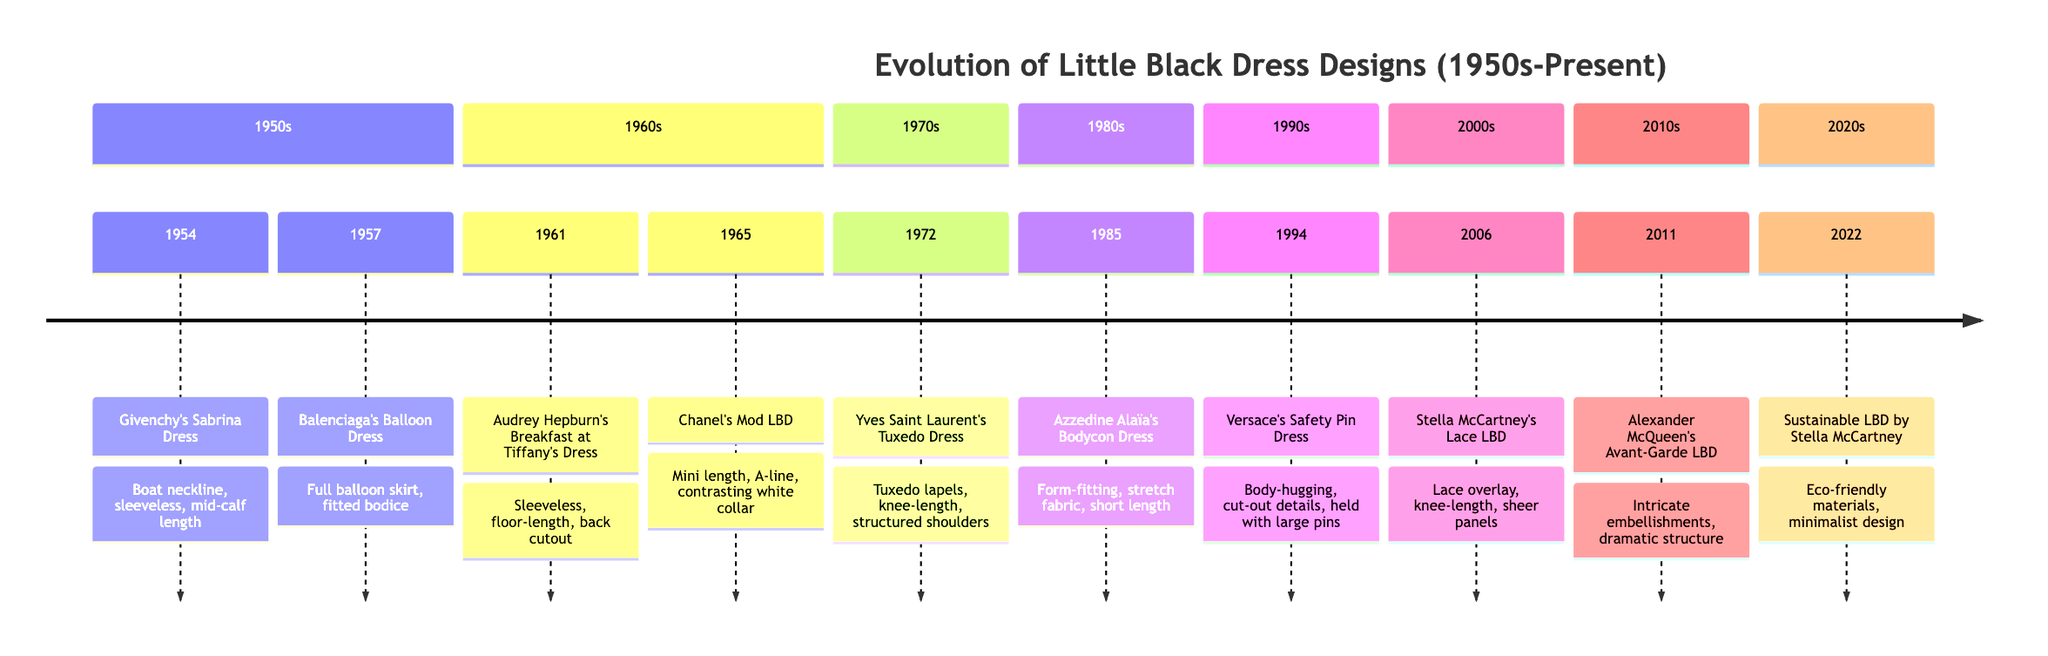What iconic dress did Audrey Hepburn wear in 1961? The diagram notes that in 1961, Audrey Hepburn wore the "Breakfast at Tiffany's Dress" designed by Hubert de Givenchy.
Answer: Breakfast at Tiffany's Dress How many key pieces are listed for the 1970s? Looking at the timeline, there is only one key piece mentioned for the 1970s, which is Yves Saint Laurent's Tuxedo Dress from 1972.
Answer: 1 Which decade introduced the bodycon style of dress? According to the diagram, the 1980s first saw the introduction of the bodycon style with Azzedine Alaïa's Bodycon Dress in 1985.
Answer: 1980s What year was Stella McCartney's Lace LBD designed? The diagram clearly indicates that Stella McCartney's Lace LBD was designed in 2006, as found in the 2000s section.
Answer: 2006 What is a key feature of Balenciaga's Balloon Dress? The timeline specifies that Balenciaga's Balloon Dress, created in 1957, features a full balloon skirt and a fitted bodice.
Answer: Full balloon skirt Which dress highlighted the androgynous style in women's fashion? The diagram states that Yves Saint Laurent's Tuxedo Dress from 1972 is the piece that introduced androgynous style to women's fashion.
Answer: Tuxedo Dress What influenced McQueen's Avant-Garde LBD in the 2010s? The timeline mentions that Alexander McQueen's Avant-Garde LBD from 2011 pushed the boundaries of the traditional LBD with artistic designs.
Answer: Artistic designs What decade marks a shift towards sustainability in LBD design? According to the timeline, the 2020s is marked by Stella McCartney's Sustainable LBD, which focuses on eco-friendly materials in fashion.
Answer: 2020s How many dresses are listed for the 1990s? The diagram indicates that there is one key piece for the 1990s, which is Versace's Safety Pin Dress from 1994.
Answer: 1 What type of materials does the Sustainable LBD utilize? The timeline notes that the Sustainable LBD by Stella McCartney uses eco-friendly materials, reflecting a modern design ethos.
Answer: Eco-friendly materials 